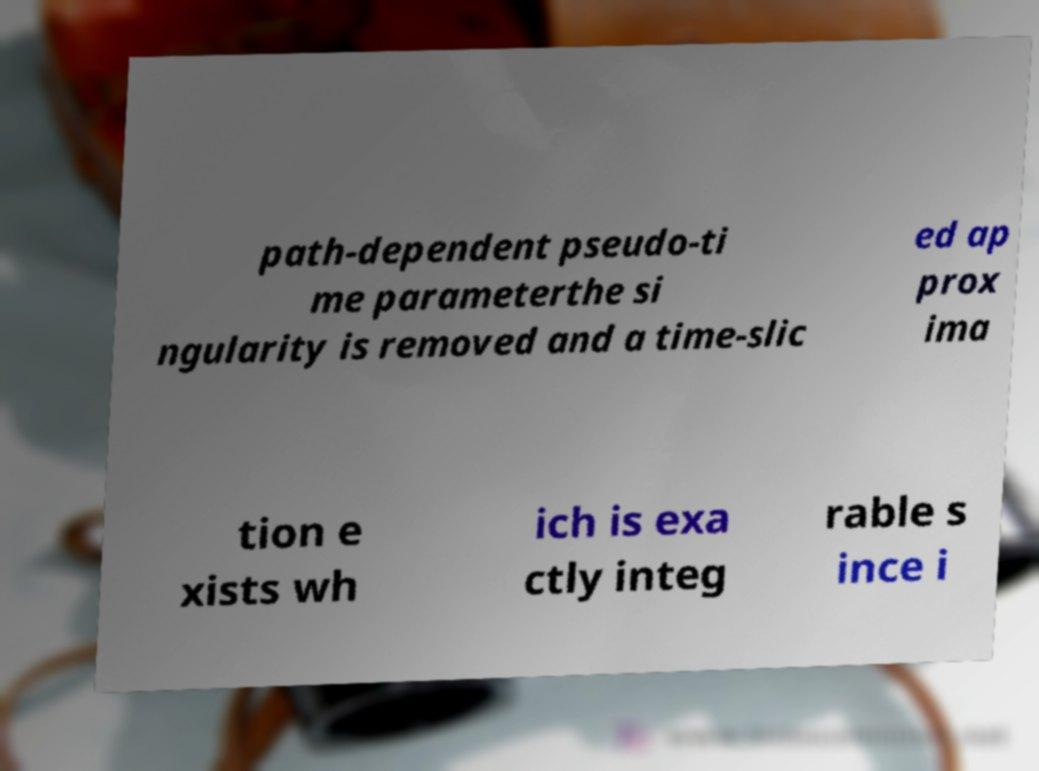I need the written content from this picture converted into text. Can you do that? path-dependent pseudo-ti me parameterthe si ngularity is removed and a time-slic ed ap prox ima tion e xists wh ich is exa ctly integ rable s ince i 